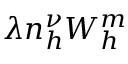Convert formula to latex. <formula><loc_0><loc_0><loc_500><loc_500>\lambda n _ { h } ^ { \nu } W _ { h } ^ { m }</formula> 